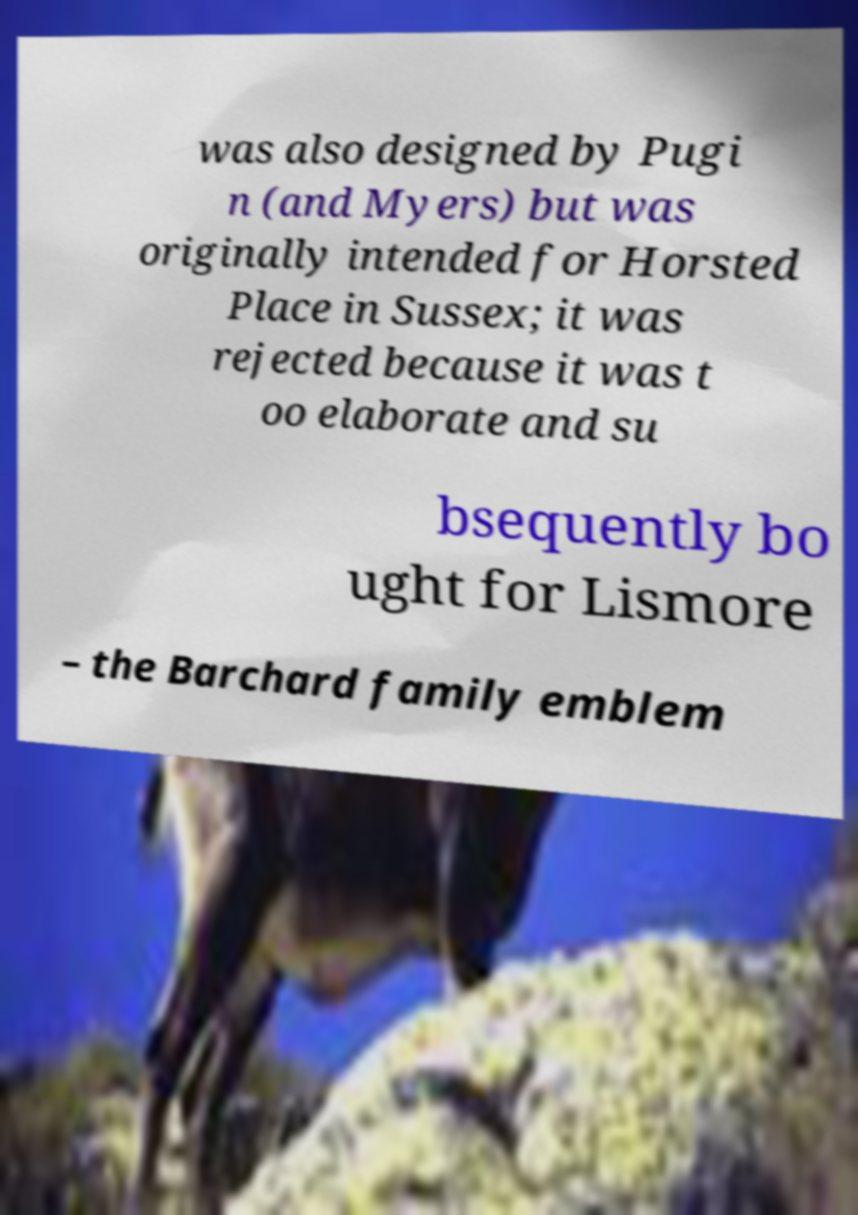For documentation purposes, I need the text within this image transcribed. Could you provide that? was also designed by Pugi n (and Myers) but was originally intended for Horsted Place in Sussex; it was rejected because it was t oo elaborate and su bsequently bo ught for Lismore – the Barchard family emblem 